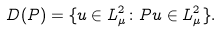<formula> <loc_0><loc_0><loc_500><loc_500>D ( P ) = \{ u \in L _ { \mu } ^ { 2 } \colon P u \in L _ { \mu } ^ { 2 } \} .</formula> 